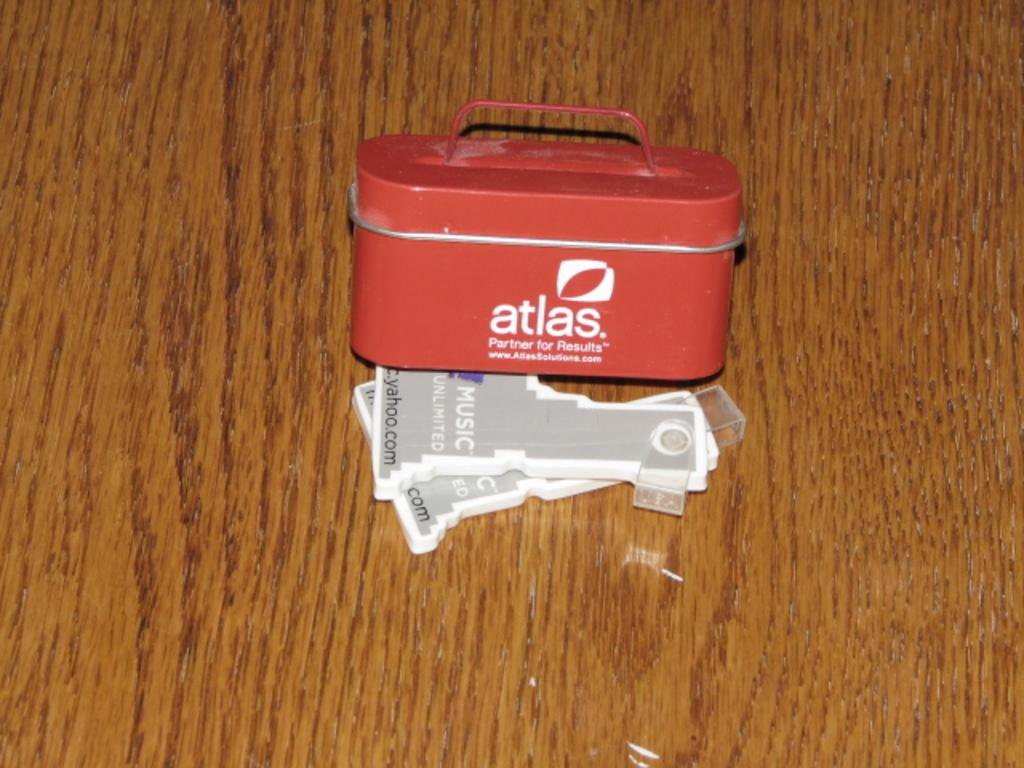<image>
Summarize the visual content of the image. A small container that reads atlas on it 